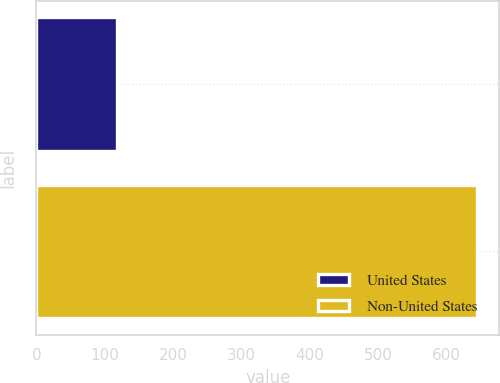Convert chart to OTSL. <chart><loc_0><loc_0><loc_500><loc_500><bar_chart><fcel>United States<fcel>Non-United States<nl><fcel>118.5<fcel>645.2<nl></chart> 